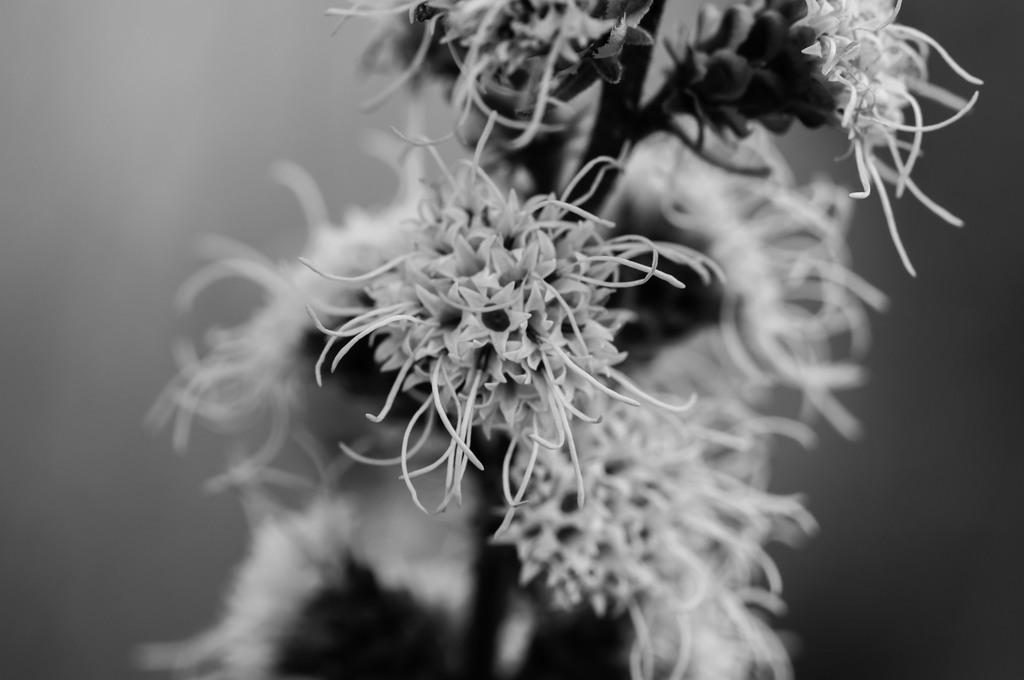What type of flowers are present in the image? There are spider flowers in the image. Are there any cherries growing on the spider flowers in the image? No, there are no cherries present in the image; it features spider flowers. Can you spot a tiger hiding among the spider flowers in the image? No, there is no tiger present in the image; it only features spider flowers. 